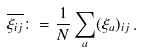<formula> <loc_0><loc_0><loc_500><loc_500>\overline { \xi _ { i j } } \colon = \frac { 1 } { N } \sum _ { a } ( \xi _ { a } ) _ { i j } \, .</formula> 